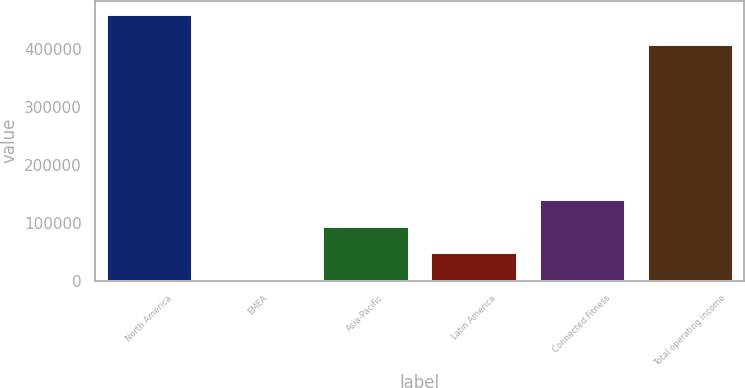<chart> <loc_0><loc_0><loc_500><loc_500><bar_chart><fcel>North America<fcel>EMEA<fcel>Asia-Pacific<fcel>Latin America<fcel>Connected Fitness<fcel>Total operating income<nl><fcel>460961<fcel>3122<fcel>94689.8<fcel>48905.9<fcel>140474<fcel>408547<nl></chart> 